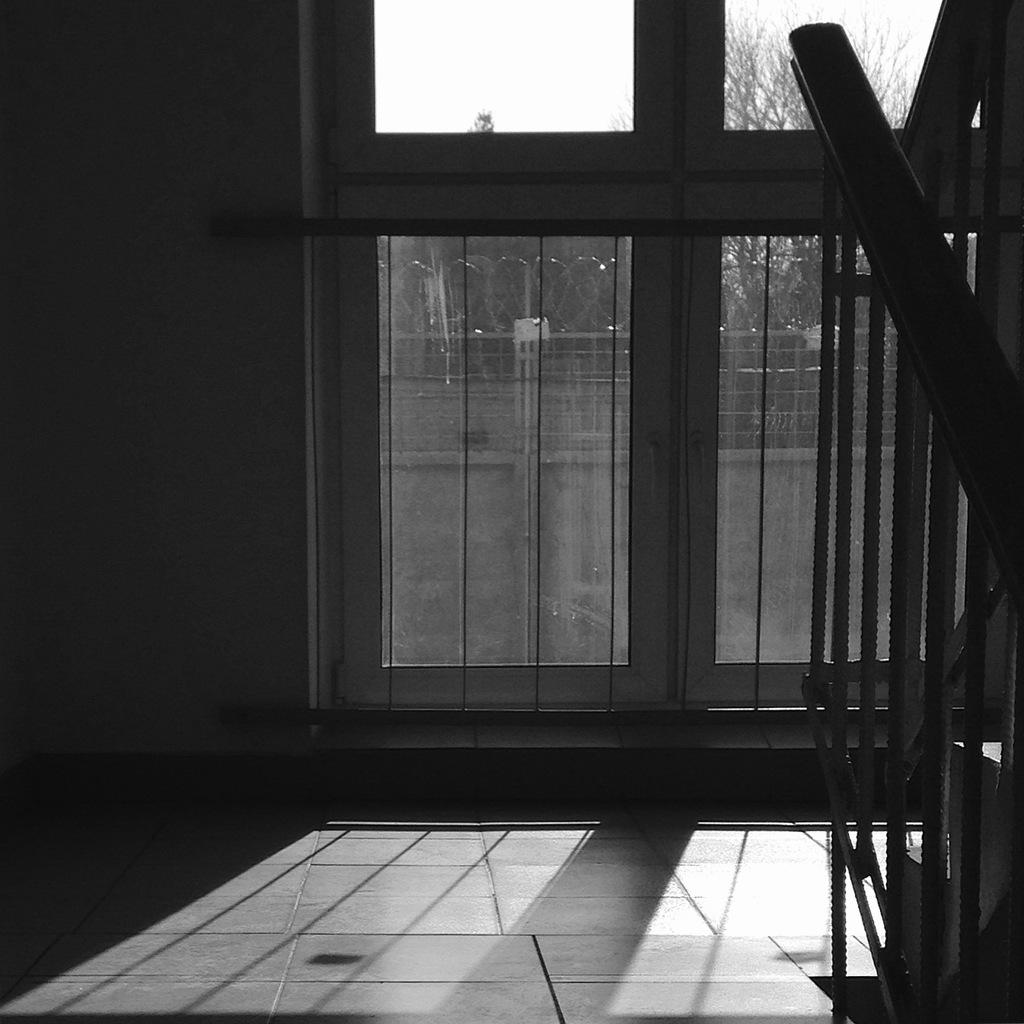What is located in the center of the image? There is a door in the center of the image. What can be seen on the right side of the image? There are stairs on the right side of the image. What is visible in the background of the image? There is fencing, a building, a tree, and the sky visible in the background of the image. How many lizards are crawling on the door in the image? There are no lizards present in the image; the door is the main subject in the center of the image. 